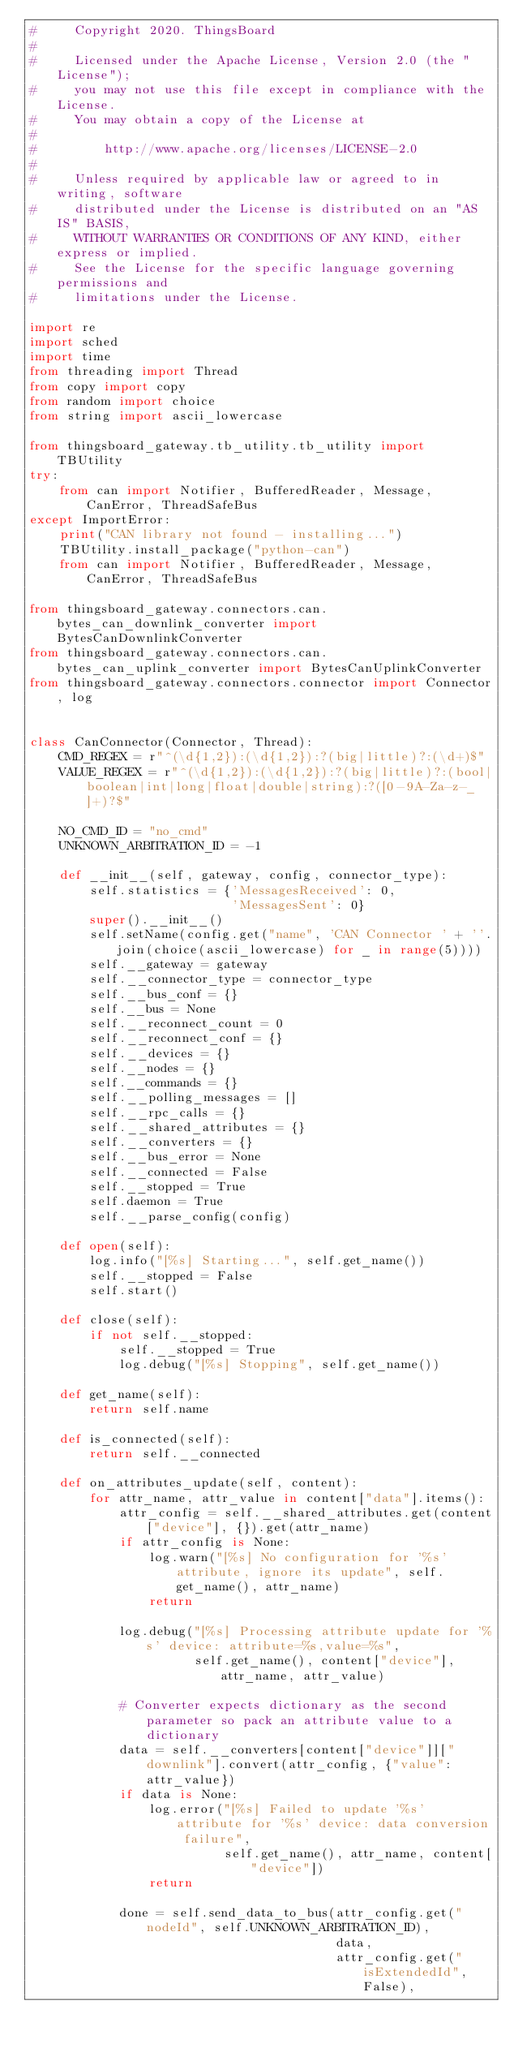Convert code to text. <code><loc_0><loc_0><loc_500><loc_500><_Python_>#     Copyright 2020. ThingsBoard
#
#     Licensed under the Apache License, Version 2.0 (the "License");
#     you may not use this file except in compliance with the License.
#     You may obtain a copy of the License at
#
#         http://www.apache.org/licenses/LICENSE-2.0
#
#     Unless required by applicable law or agreed to in writing, software
#     distributed under the License is distributed on an "AS IS" BASIS,
#     WITHOUT WARRANTIES OR CONDITIONS OF ANY KIND, either express or implied.
#     See the License for the specific language governing permissions and
#     limitations under the License.

import re
import sched
import time
from threading import Thread
from copy import copy
from random import choice
from string import ascii_lowercase

from thingsboard_gateway.tb_utility.tb_utility import TBUtility
try:
    from can import Notifier, BufferedReader, Message, CanError, ThreadSafeBus
except ImportError:
    print("CAN library not found - installing...")
    TBUtility.install_package("python-can")
    from can import Notifier, BufferedReader, Message, CanError, ThreadSafeBus

from thingsboard_gateway.connectors.can.bytes_can_downlink_converter import BytesCanDownlinkConverter
from thingsboard_gateway.connectors.can.bytes_can_uplink_converter import BytesCanUplinkConverter
from thingsboard_gateway.connectors.connector import Connector, log


class CanConnector(Connector, Thread):
    CMD_REGEX = r"^(\d{1,2}):(\d{1,2}):?(big|little)?:(\d+)$"
    VALUE_REGEX = r"^(\d{1,2}):(\d{1,2}):?(big|little)?:(bool|boolean|int|long|float|double|string):?([0-9A-Za-z-_]+)?$"

    NO_CMD_ID = "no_cmd"
    UNKNOWN_ARBITRATION_ID = -1

    def __init__(self, gateway, config, connector_type):
        self.statistics = {'MessagesReceived': 0,
                           'MessagesSent': 0}
        super().__init__()
        self.setName(config.get("name", 'CAN Connector ' + ''.join(choice(ascii_lowercase) for _ in range(5))))
        self.__gateway = gateway
        self.__connector_type = connector_type
        self.__bus_conf = {}
        self.__bus = None
        self.__reconnect_count = 0
        self.__reconnect_conf = {}
        self.__devices = {}
        self.__nodes = {}
        self.__commands = {}
        self.__polling_messages = []
        self.__rpc_calls = {}
        self.__shared_attributes = {}
        self.__converters = {}
        self.__bus_error = None
        self.__connected = False
        self.__stopped = True
        self.daemon = True
        self.__parse_config(config)

    def open(self):
        log.info("[%s] Starting...", self.get_name())
        self.__stopped = False
        self.start()

    def close(self):
        if not self.__stopped:
            self.__stopped = True
            log.debug("[%s] Stopping", self.get_name())

    def get_name(self):
        return self.name

    def is_connected(self):
        return self.__connected

    def on_attributes_update(self, content):
        for attr_name, attr_value in content["data"].items():
            attr_config = self.__shared_attributes.get(content["device"], {}).get(attr_name)
            if attr_config is None:
                log.warn("[%s] No configuration for '%s' attribute, ignore its update", self.get_name(), attr_name)
                return

            log.debug("[%s] Processing attribute update for '%s' device: attribute=%s,value=%s",
                      self.get_name(), content["device"], attr_name, attr_value)

            # Converter expects dictionary as the second parameter so pack an attribute value to a dictionary
            data = self.__converters[content["device"]]["downlink"].convert(attr_config, {"value": attr_value})
            if data is None:
                log.error("[%s] Failed to update '%s' attribute for '%s' device: data conversion failure",
                          self.get_name(), attr_name, content["device"])
                return

            done = self.send_data_to_bus(attr_config.get("nodeId", self.UNKNOWN_ARBITRATION_ID),
                                         data,
                                         attr_config.get("isExtendedId", False),</code> 